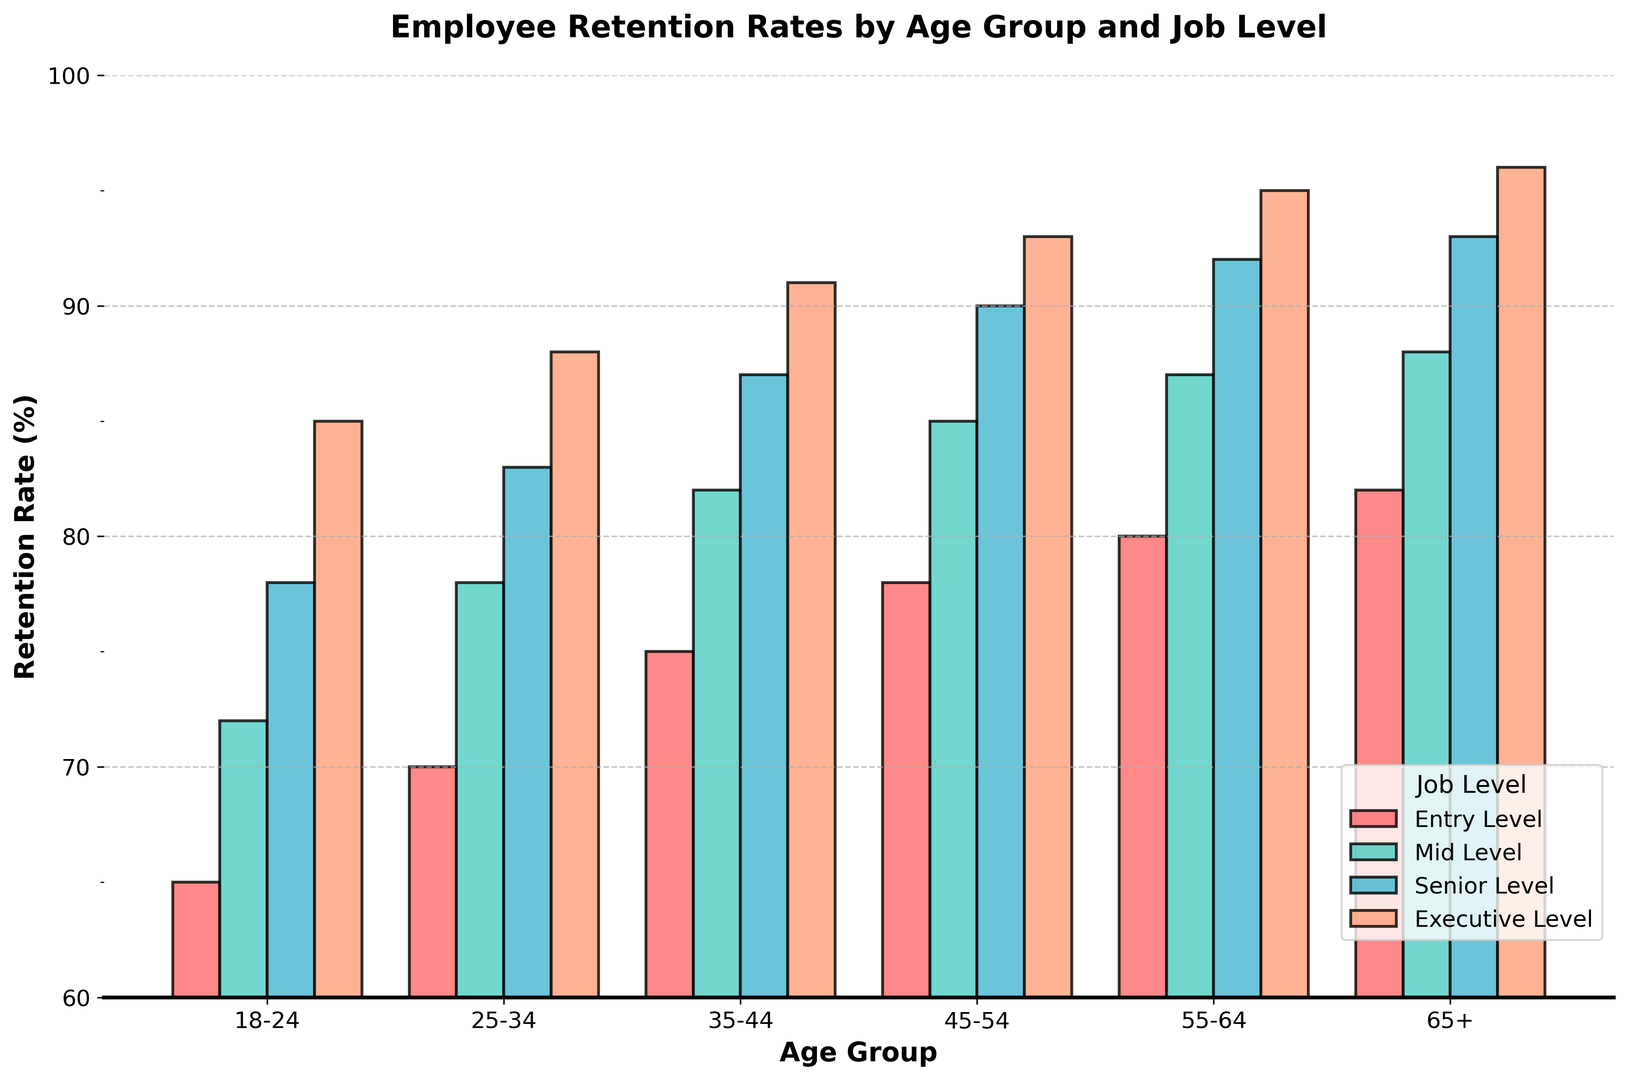Which age group has the highest retention rate at the Entry Level? The Entry Level bar for the 65+ age group is the highest among all age groups.
Answer: 65+ Which job level shows the smallest difference in retention rates between the 18-24 and 65+ age groups? For the 18-24 age group, the retention rates are: Entry Level (65), Mid Level (72), Senior Level (78), and Executive Level (85). For the 65+ age group, the rates are: Entry Level (82), Mid Level (88), Senior Level (93), and Executive Level (96). The differences are: Entry Level (82-65=17), Mid Level (88-72=16), Senior Level (93-78=15), and Executive Level (96-85=11). The smallest difference is for the Executive Level.
Answer: Executive Level What is the average retention rate for the 35-44 age group across all job levels? The retention rates for the 35-44 age group are: Entry Level (75), Mid Level (82), Senior Level (87), and Executive Level (91). The average is calculated as (75 + 82 + 87 + 91) / 4 = 84.
Answer: 84 Which age group has the smallest range of retention rates across different job levels? For each age group, calculate the range (difference between the highest and lowest retention rates):
18-24: 85 - 65 = 20 
25-34: 88 - 70 = 18 
35-44: 91 - 75 = 16 
45-54: 93 - 78 = 15 
55-64: 95 - 80 = 15 
65+: 96 - 82 = 14 
The smallest range is for the 65+ age group with a range of 14.
Answer: 65+ Which job level consistently has retention rates above 90% for the 45+ age groups? Examine the retention rates for the 45-54, 55-64, and 65+ age groups: Entry Level (78, 80, 82), Mid Level (85, 87, 88), Senior Level (90, 92, 93), and Executive Level (93, 95, 96). Only the Executive Level has retention rates above 90% consistently.
Answer: Executive Level By how much does the retention rate for the Executive Level increase from the 35-44 age group to the 65+ age group? The retention rate for the Executive Level in the 35-44 age group is 91%, and for the 65+ age group, it is 96%. The increase is 96 - 91 = 5%.
Answer: 5% Between which two consecutive age groups is the largest increase in retention rate observed for the Mid Level job level? Calculate the differences in retention rates for Mid Level between consecutive age groups:
18-24 to 25-34: 78 - 72 = 6 
25-34 to 35-44: 82 - 78 = 4 
35-44 to 45-54: 85 - 82 = 3 
45-54 to 55-64: 87 - 85 = 2 
55-64 to 65+: 88 - 87 = 1 
The largest increase is between the 18-24 and 25-34 age groups, which is 6.
Answer: 18-24 to 25-34 Which color represents the retention rate for Mid Level job level on the plot? By examining the colors used in the plot, the Mid Level job level bars are represented by the color green.
Answer: Green 